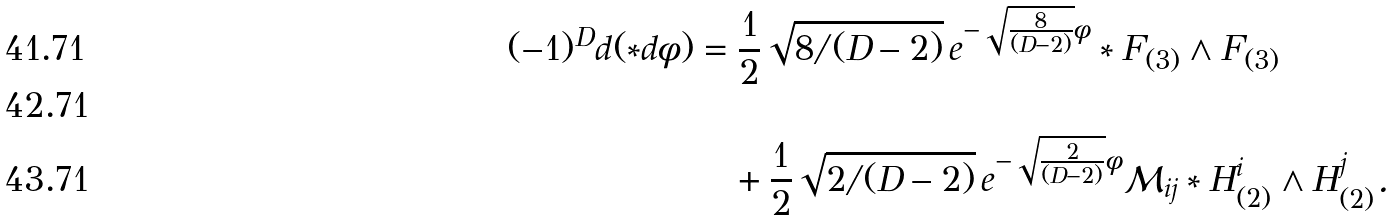<formula> <loc_0><loc_0><loc_500><loc_500>( - 1 ) ^ { D } d ( \ast d \phi ) & = \frac { 1 } { 2 } \sqrt { 8 / ( D - 2 ) } \, e ^ { - \sqrt { \frac { 8 } { ( D - 2 ) } } \phi } \ast F _ { ( 3 ) } \wedge F _ { ( 3 ) } \\ \\ & \quad + \frac { 1 } { 2 } \sqrt { 2 / ( D - 2 ) } \, e ^ { - \sqrt { \frac { 2 } { ( D - 2 ) } } \phi } \mathcal { M } _ { i j } \ast H _ { ( 2 ) } ^ { i } \wedge H _ { ( 2 ) } ^ { j } .</formula> 